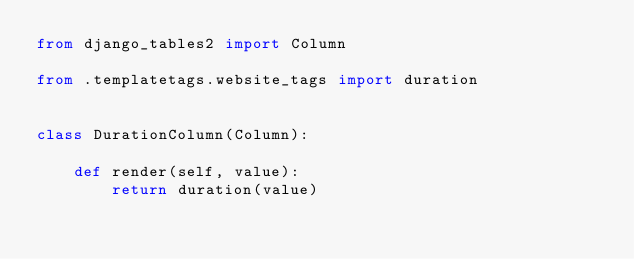Convert code to text. <code><loc_0><loc_0><loc_500><loc_500><_Python_>from django_tables2 import Column

from .templatetags.website_tags import duration


class DurationColumn(Column):

    def render(self, value):
        return duration(value)
</code> 